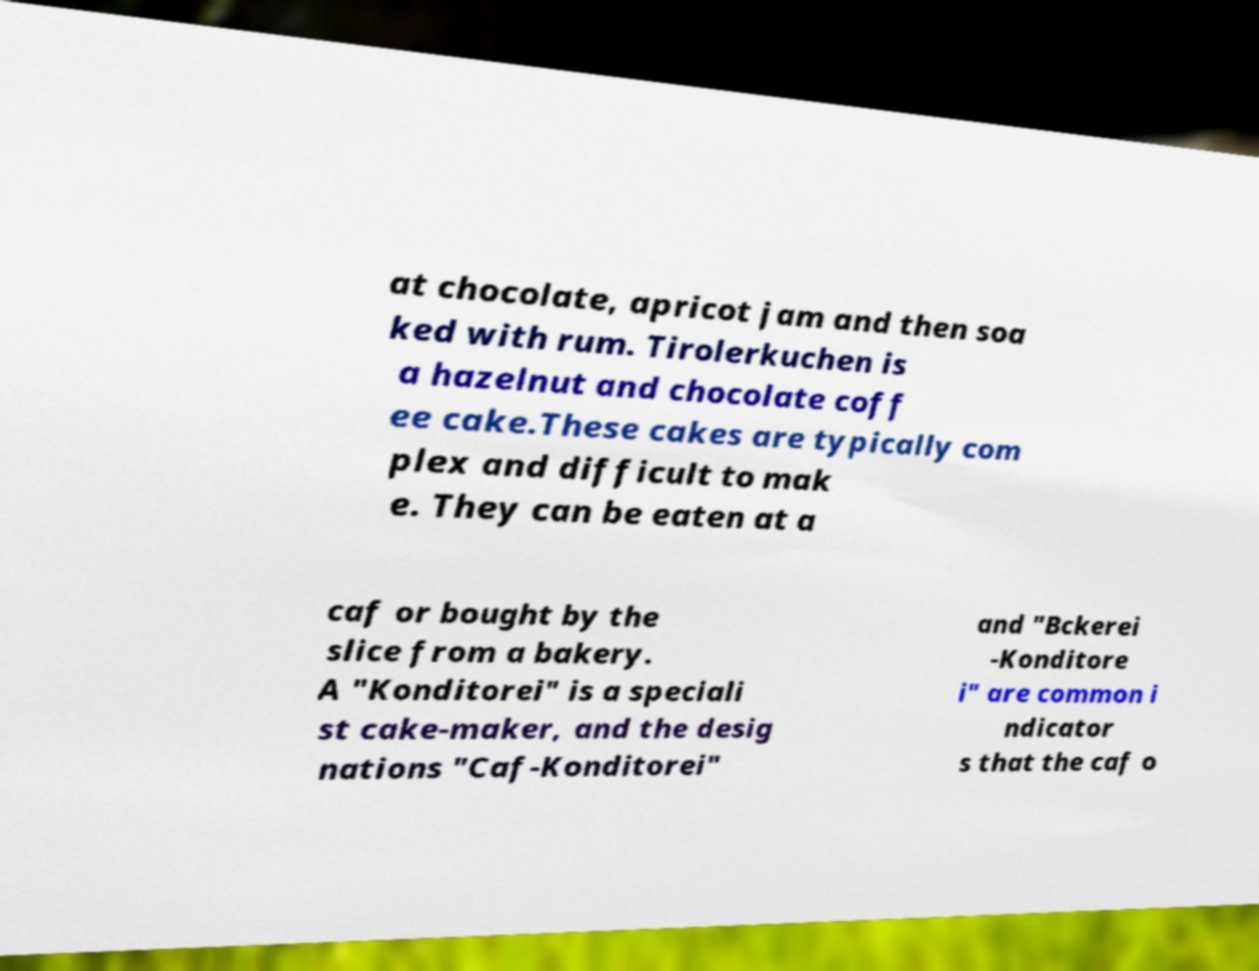Can you read and provide the text displayed in the image?This photo seems to have some interesting text. Can you extract and type it out for me? at chocolate, apricot jam and then soa ked with rum. Tirolerkuchen is a hazelnut and chocolate coff ee cake.These cakes are typically com plex and difficult to mak e. They can be eaten at a caf or bought by the slice from a bakery. A "Konditorei" is a speciali st cake-maker, and the desig nations "Caf-Konditorei" and "Bckerei -Konditore i" are common i ndicator s that the caf o 